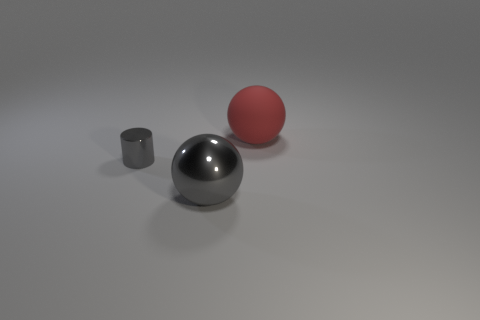There is a big metallic ball; does it have the same color as the metallic cylinder left of the large red object?
Offer a terse response. Yes. There is a thing that is the same color as the large metallic sphere; what material is it?
Give a very brief answer. Metal. Is there anything else that is the same shape as the large matte thing?
Provide a short and direct response. Yes. What is the shape of the large thing that is left of the big object behind the gray metal thing that is on the left side of the large metallic sphere?
Your answer should be very brief. Sphere. The red object has what shape?
Your answer should be compact. Sphere. There is a sphere behind the big metal sphere; what is its color?
Make the answer very short. Red. There is a ball in front of the metallic cylinder; is it the same size as the red object?
Ensure brevity in your answer.  Yes. What is the size of the other metal object that is the same shape as the red object?
Provide a short and direct response. Large. Is there any other thing that has the same size as the red ball?
Your answer should be very brief. Yes. Is the large red matte object the same shape as the tiny thing?
Provide a short and direct response. No. 